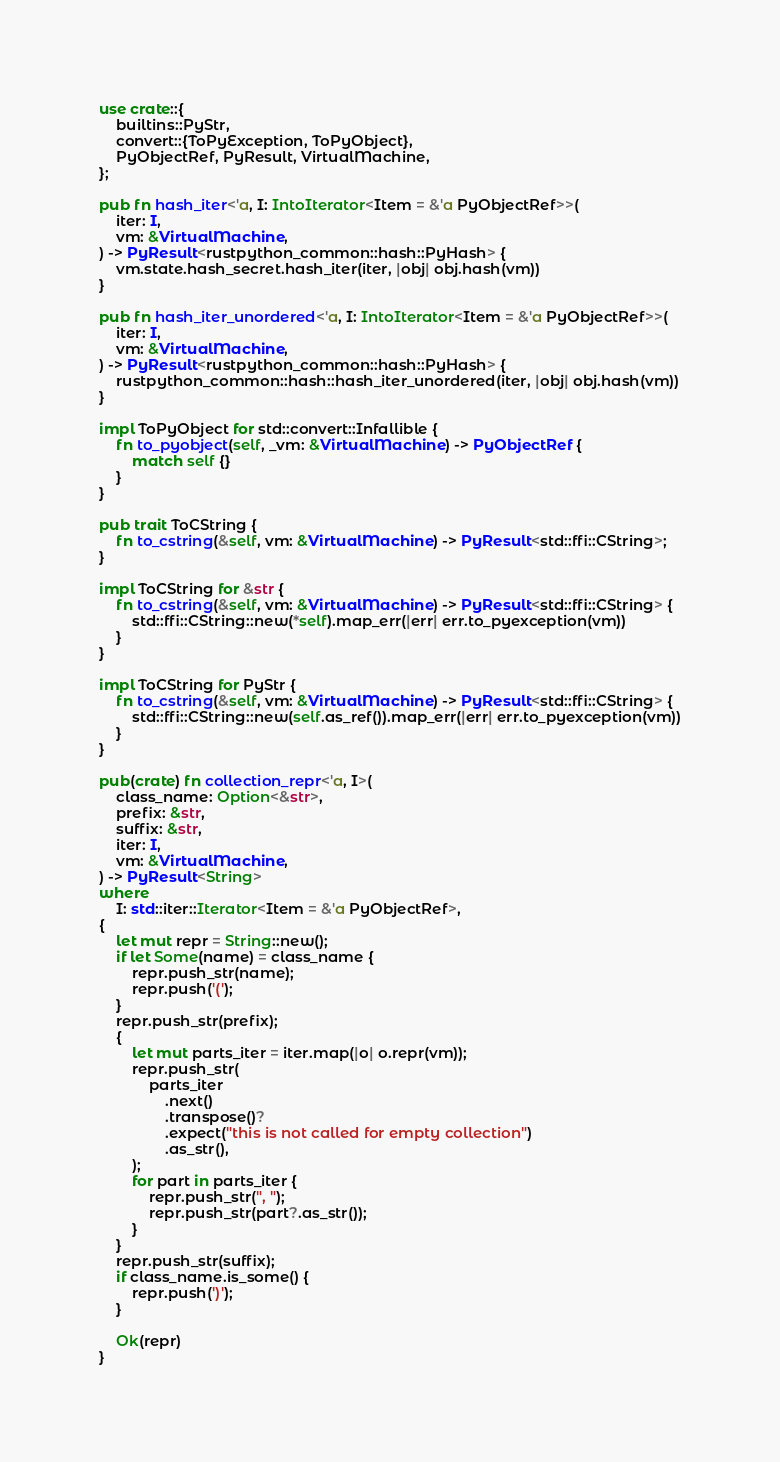Convert code to text. <code><loc_0><loc_0><loc_500><loc_500><_Rust_>use crate::{
    builtins::PyStr,
    convert::{ToPyException, ToPyObject},
    PyObjectRef, PyResult, VirtualMachine,
};

pub fn hash_iter<'a, I: IntoIterator<Item = &'a PyObjectRef>>(
    iter: I,
    vm: &VirtualMachine,
) -> PyResult<rustpython_common::hash::PyHash> {
    vm.state.hash_secret.hash_iter(iter, |obj| obj.hash(vm))
}

pub fn hash_iter_unordered<'a, I: IntoIterator<Item = &'a PyObjectRef>>(
    iter: I,
    vm: &VirtualMachine,
) -> PyResult<rustpython_common::hash::PyHash> {
    rustpython_common::hash::hash_iter_unordered(iter, |obj| obj.hash(vm))
}

impl ToPyObject for std::convert::Infallible {
    fn to_pyobject(self, _vm: &VirtualMachine) -> PyObjectRef {
        match self {}
    }
}

pub trait ToCString {
    fn to_cstring(&self, vm: &VirtualMachine) -> PyResult<std::ffi::CString>;
}

impl ToCString for &str {
    fn to_cstring(&self, vm: &VirtualMachine) -> PyResult<std::ffi::CString> {
        std::ffi::CString::new(*self).map_err(|err| err.to_pyexception(vm))
    }
}

impl ToCString for PyStr {
    fn to_cstring(&self, vm: &VirtualMachine) -> PyResult<std::ffi::CString> {
        std::ffi::CString::new(self.as_ref()).map_err(|err| err.to_pyexception(vm))
    }
}

pub(crate) fn collection_repr<'a, I>(
    class_name: Option<&str>,
    prefix: &str,
    suffix: &str,
    iter: I,
    vm: &VirtualMachine,
) -> PyResult<String>
where
    I: std::iter::Iterator<Item = &'a PyObjectRef>,
{
    let mut repr = String::new();
    if let Some(name) = class_name {
        repr.push_str(name);
        repr.push('(');
    }
    repr.push_str(prefix);
    {
        let mut parts_iter = iter.map(|o| o.repr(vm));
        repr.push_str(
            parts_iter
                .next()
                .transpose()?
                .expect("this is not called for empty collection")
                .as_str(),
        );
        for part in parts_iter {
            repr.push_str(", ");
            repr.push_str(part?.as_str());
        }
    }
    repr.push_str(suffix);
    if class_name.is_some() {
        repr.push(')');
    }

    Ok(repr)
}
</code> 